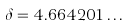Convert formula to latex. <formula><loc_0><loc_0><loc_500><loc_500>\delta = 4 . 6 6 4 2 0 1 \dots</formula> 